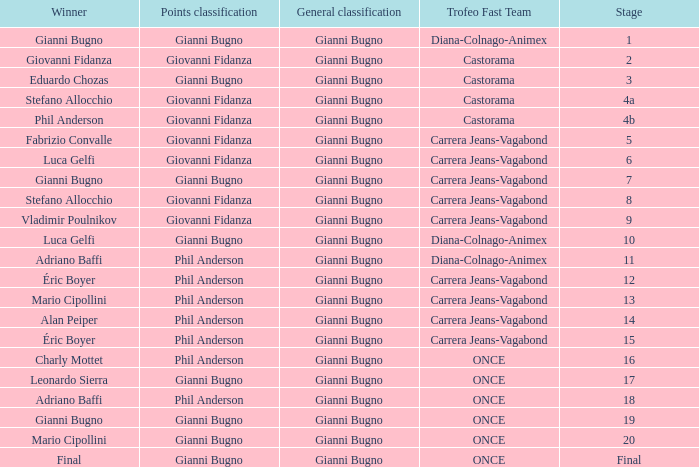I'm looking to parse the entire table for insights. Could you assist me with that? {'header': ['Winner', 'Points classification', 'General classification', 'Trofeo Fast Team', 'Stage'], 'rows': [['Gianni Bugno', 'Gianni Bugno', 'Gianni Bugno', 'Diana-Colnago-Animex', '1'], ['Giovanni Fidanza', 'Giovanni Fidanza', 'Gianni Bugno', 'Castorama', '2'], ['Eduardo Chozas', 'Gianni Bugno', 'Gianni Bugno', 'Castorama', '3'], ['Stefano Allocchio', 'Giovanni Fidanza', 'Gianni Bugno', 'Castorama', '4a'], ['Phil Anderson', 'Giovanni Fidanza', 'Gianni Bugno', 'Castorama', '4b'], ['Fabrizio Convalle', 'Giovanni Fidanza', 'Gianni Bugno', 'Carrera Jeans-Vagabond', '5'], ['Luca Gelfi', 'Giovanni Fidanza', 'Gianni Bugno', 'Carrera Jeans-Vagabond', '6'], ['Gianni Bugno', 'Gianni Bugno', 'Gianni Bugno', 'Carrera Jeans-Vagabond', '7'], ['Stefano Allocchio', 'Giovanni Fidanza', 'Gianni Bugno', 'Carrera Jeans-Vagabond', '8'], ['Vladimir Poulnikov', 'Giovanni Fidanza', 'Gianni Bugno', 'Carrera Jeans-Vagabond', '9'], ['Luca Gelfi', 'Gianni Bugno', 'Gianni Bugno', 'Diana-Colnago-Animex', '10'], ['Adriano Baffi', 'Phil Anderson', 'Gianni Bugno', 'Diana-Colnago-Animex', '11'], ['Éric Boyer', 'Phil Anderson', 'Gianni Bugno', 'Carrera Jeans-Vagabond', '12'], ['Mario Cipollini', 'Phil Anderson', 'Gianni Bugno', 'Carrera Jeans-Vagabond', '13'], ['Alan Peiper', 'Phil Anderson', 'Gianni Bugno', 'Carrera Jeans-Vagabond', '14'], ['Éric Boyer', 'Phil Anderson', 'Gianni Bugno', 'Carrera Jeans-Vagabond', '15'], ['Charly Mottet', 'Phil Anderson', 'Gianni Bugno', 'ONCE', '16'], ['Leonardo Sierra', 'Gianni Bugno', 'Gianni Bugno', 'ONCE', '17'], ['Adriano Baffi', 'Phil Anderson', 'Gianni Bugno', 'ONCE', '18'], ['Gianni Bugno', 'Gianni Bugno', 'Gianni Bugno', 'ONCE', '19'], ['Mario Cipollini', 'Gianni Bugno', 'Gianni Bugno', 'ONCE', '20'], ['Final', 'Gianni Bugno', 'Gianni Bugno', 'ONCE', 'Final']]} Who is the points classification in stage 1? Gianni Bugno. 